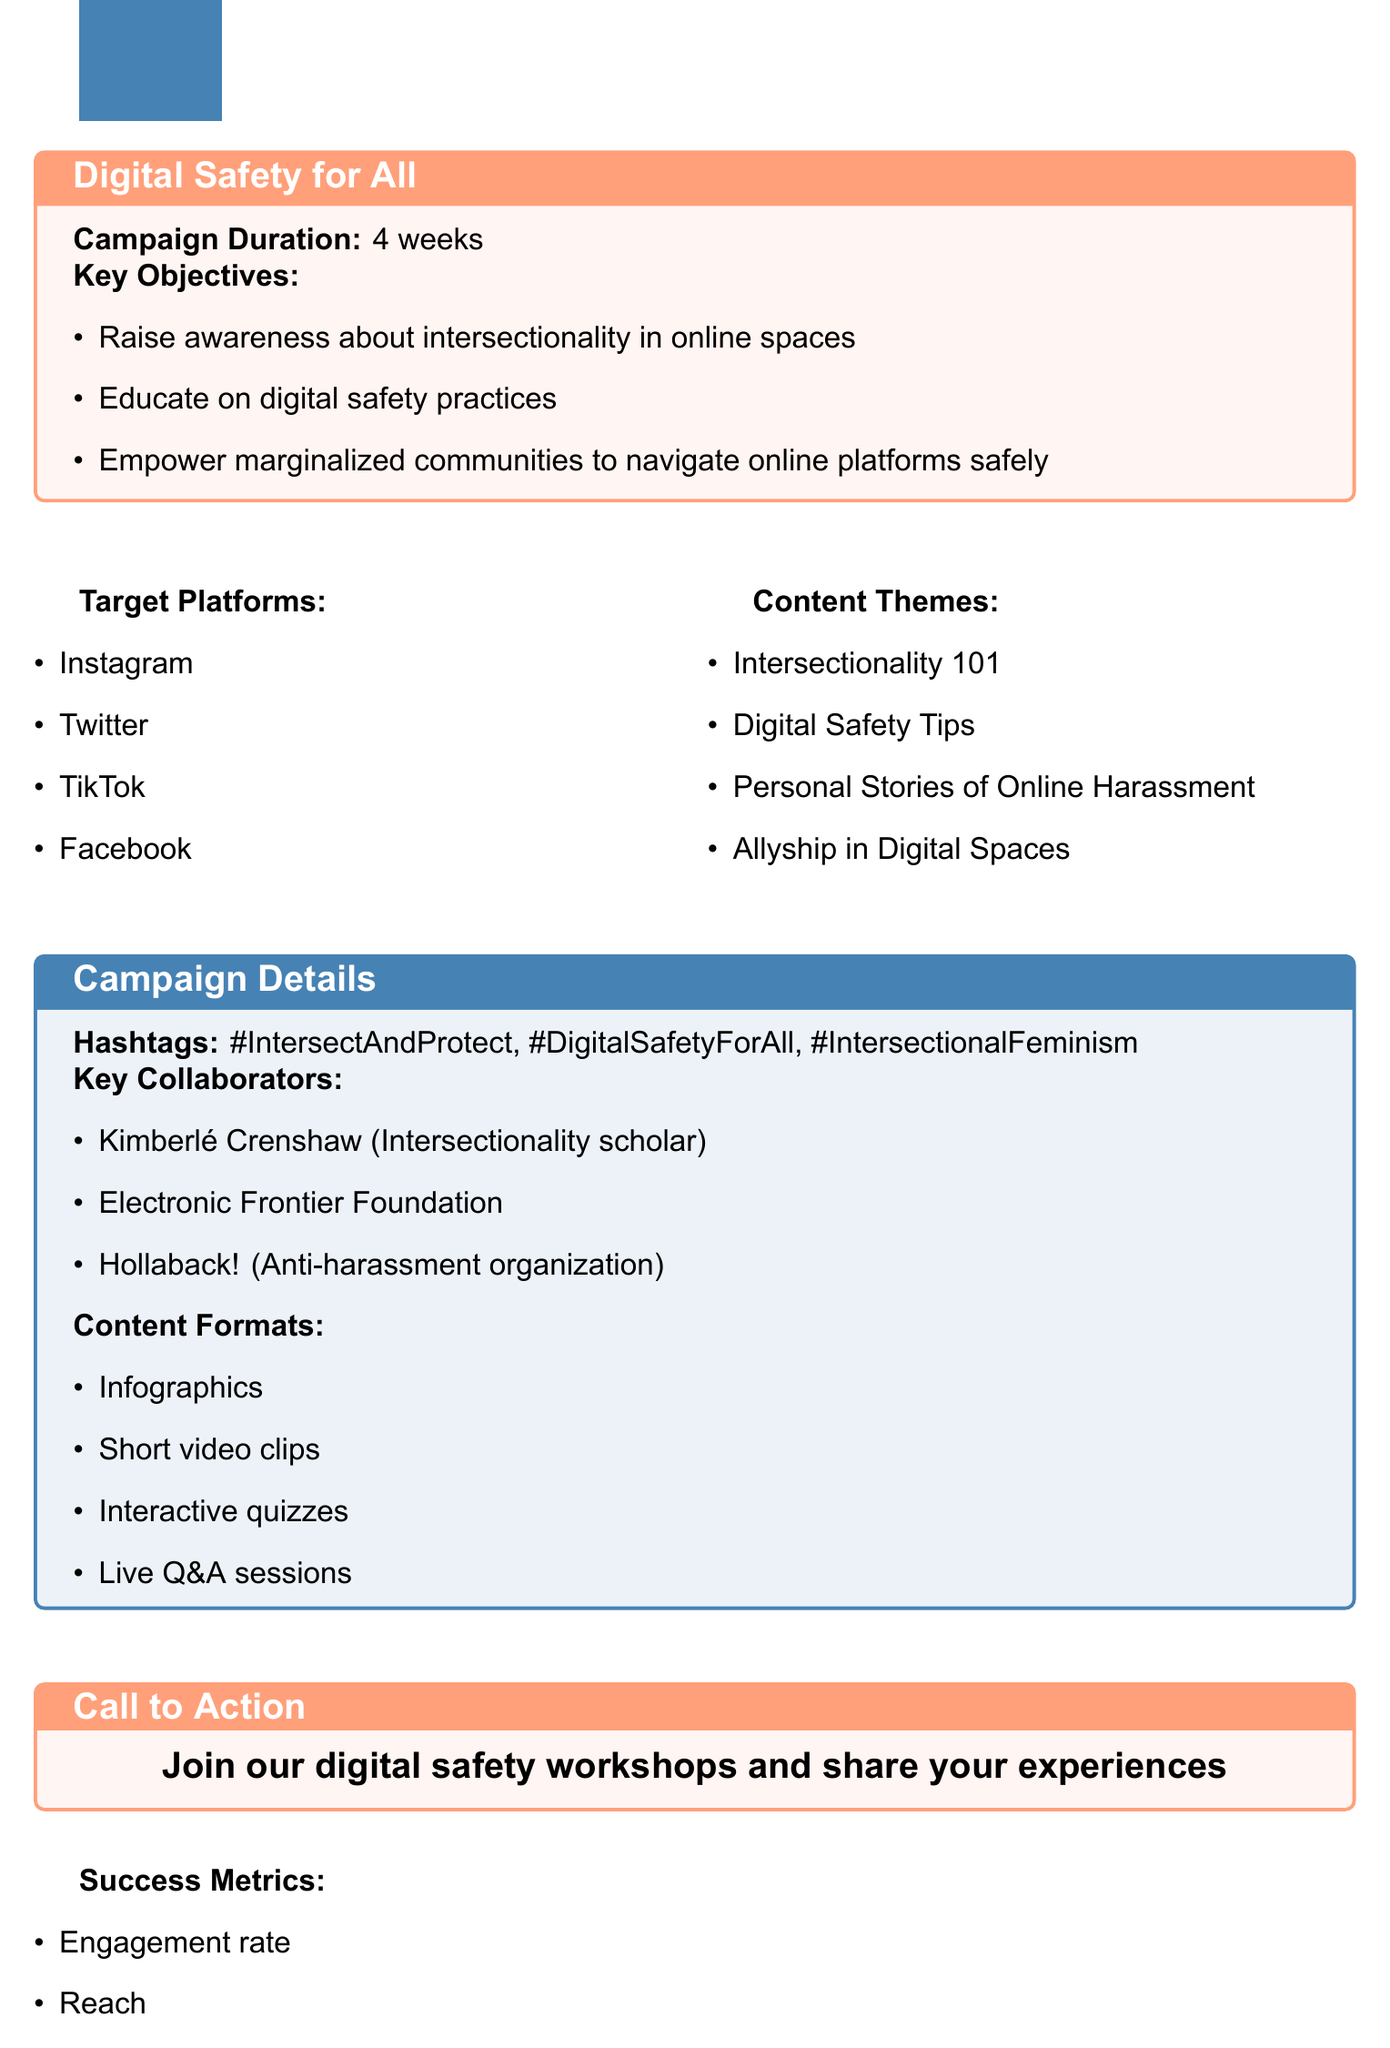What is the campaign title? The title of the campaign is stated at the beginning of the document as the main focus of the notes.
Answer: Intersect & Protect: Digital Safety for All How long is the campaign duration? The duration of the campaign is explicitly mentioned as a specific time frame in the document.
Answer: 4 weeks Name one of the key objectives of the campaign. The document lists several objectives that the campaign aims to achieve, allowing for a straightforward retrieval of individual goals.
Answer: Raise awareness about intersectionality in online spaces What are the target platforms for the campaign? The document provides a list of platforms where the campaign will be active, covering various social media spaces.
Answer: Instagram, Twitter, TikTok, Facebook How many content themes are listed in the document? By counting the items in the content themes section of the document, we can determine the total number.
Answer: 4 Who is one of the key collaborators mentioned? The document specifically names collaborators that are integral to the campaign, allowing for easy identification of individuals or organizations involved.
Answer: Kimberlé Crenshaw What is the call to action for the campaign? The document succinctly states the desired action for the audience, serving as an invitation or encouragement to participate.
Answer: Join our digital safety workshops and share your experiences What success metric includes engagement rates? The document lists multiple metrics that the campaign will use to assess its effectiveness, allowing for the identification of specific types.
Answer: Engagement rate What content format will be used in the campaign? The document outlines several formats that will be employed in the campaign, providing a clear view of the media strategy.
Answer: Infographics 